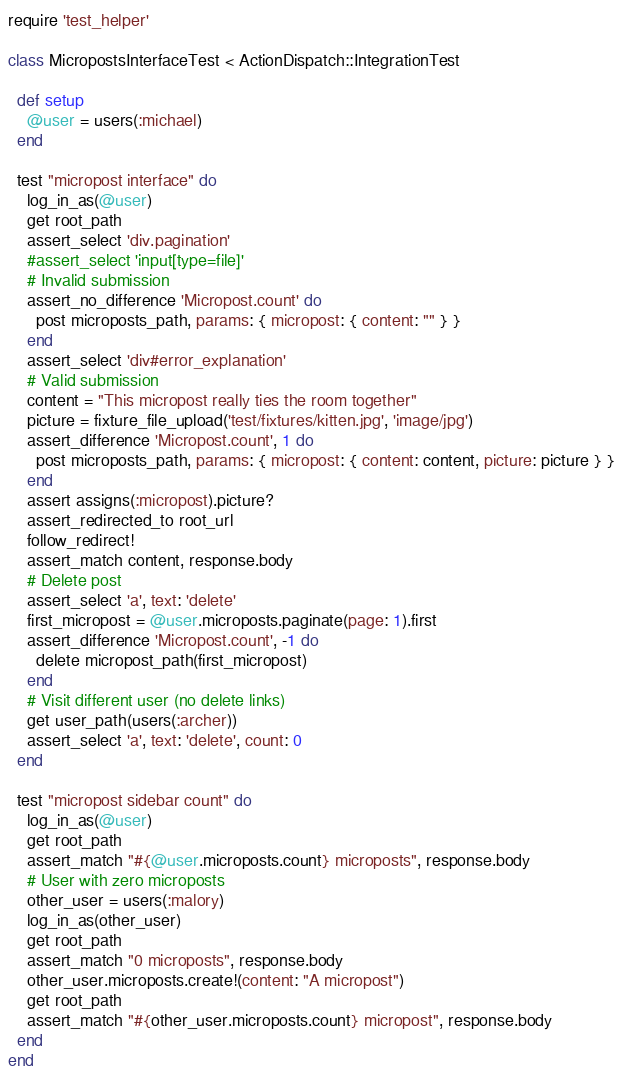Convert code to text. <code><loc_0><loc_0><loc_500><loc_500><_Ruby_>require 'test_helper'

class MicropostsInterfaceTest < ActionDispatch::IntegrationTest

  def setup
    @user = users(:michael)
  end

  test "micropost interface" do
    log_in_as(@user)
    get root_path
    assert_select 'div.pagination'
    #assert_select 'input[type=file]'
    # Invalid submission
    assert_no_difference 'Micropost.count' do
      post microposts_path, params: { micropost: { content: "" } }
    end
    assert_select 'div#error_explanation'
    # Valid submission
    content = "This micropost really ties the room together"
    picture = fixture_file_upload('test/fixtures/kitten.jpg', 'image/jpg')
    assert_difference 'Micropost.count', 1 do
      post microposts_path, params: { micropost: { content: content, picture: picture } }
    end
    assert assigns(:micropost).picture?
    assert_redirected_to root_url
    follow_redirect!
    assert_match content, response.body
    # Delete post
    assert_select 'a', text: 'delete'
    first_micropost = @user.microposts.paginate(page: 1).first
    assert_difference 'Micropost.count', -1 do
      delete micropost_path(first_micropost)
    end
    # Visit different user (no delete links)
    get user_path(users(:archer))
    assert_select 'a', text: 'delete', count: 0
  end

  test "micropost sidebar count" do
    log_in_as(@user)
    get root_path
    assert_match "#{@user.microposts.count} microposts", response.body
    # User with zero microposts
    other_user = users(:malory)
    log_in_as(other_user)
    get root_path
    assert_match "0 microposts", response.body
    other_user.microposts.create!(content: "A micropost")
    get root_path
    assert_match "#{other_user.microposts.count} micropost", response.body
  end
end
</code> 